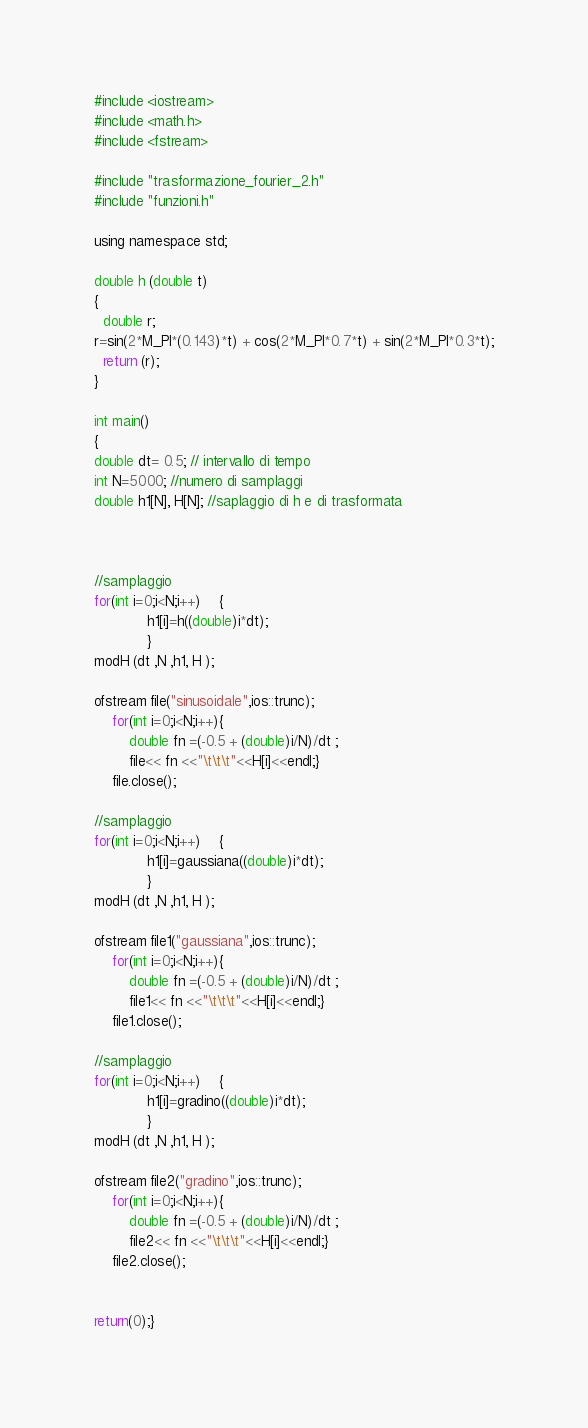<code> <loc_0><loc_0><loc_500><loc_500><_C_>#include <iostream>
#include <math.h>
#include <fstream>

#include "trasformazione_fourier_2.h"
#include "funzioni.h"

using namespace std;

double h (double t) 
{
  double r;
r=sin(2*M_PI*(0.143)*t) + cos(2*M_PI*0.7*t) + sin(2*M_PI*0.3*t);
  return (r);
}

int main()
{
double dt= 0.5; // intervallo di tempo
int N=5000; //numero di samplaggi
double h1[N], H[N]; //saplaggio di h e di trasformata



//samplaggio
for(int i=0;i<N;i++)	{
			h1[i]=h((double)i*dt);
			}
modH (dt ,N ,h1, H );

ofstream file("sinusoidale",ios::trunc);
	for(int i=0;i<N;i++){
		double fn =(-0.5 + (double)i/N)/dt ;	
		file<< fn <<"\t\t\t"<<H[i]<<endl;}
	file.close();

//samplaggio
for(int i=0;i<N;i++)	{
			h1[i]=gaussiana((double)i*dt);
			}
modH (dt ,N ,h1, H );

ofstream file1("gaussiana",ios::trunc);
	for(int i=0;i<N;i++){
		double fn =(-0.5 + (double)i/N)/dt ;	
		file1<< fn <<"\t\t\t"<<H[i]<<endl;}
	file1.close();

//samplaggio
for(int i=0;i<N;i++)	{
			h1[i]=gradino((double)i*dt);
			}
modH (dt ,N ,h1, H );

ofstream file2("gradino",ios::trunc);
	for(int i=0;i<N;i++){
		double fn =(-0.5 + (double)i/N)/dt ;	
		file2<< fn <<"\t\t\t"<<H[i]<<endl;}
	file2.close();


return(0);}
</code> 